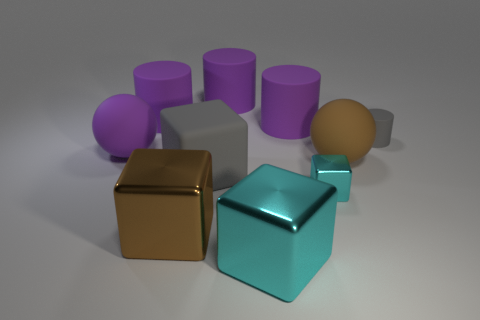Subtract all brown cubes. How many cubes are left? 3 Subtract all blue blocks. How many purple cylinders are left? 3 Subtract all gray cylinders. How many cylinders are left? 3 Subtract 2 cubes. How many cubes are left? 2 Subtract all cylinders. How many objects are left? 6 Add 5 small cyan blocks. How many small cyan blocks are left? 6 Add 8 big brown metal things. How many big brown metal things exist? 9 Subtract 0 red balls. How many objects are left? 10 Subtract all cyan cylinders. Subtract all gray balls. How many cylinders are left? 4 Subtract all cylinders. Subtract all brown blocks. How many objects are left? 5 